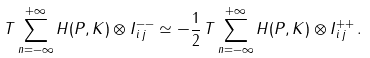Convert formula to latex. <formula><loc_0><loc_0><loc_500><loc_500>T \sum _ { n = - \infty } ^ { + \infty } H ( P , K ) \otimes I ^ { - - } _ { \, i \, j } \simeq - \frac { 1 } { 2 } \, T \sum _ { n = - \infty } ^ { + \infty } H ( P , K ) \otimes I ^ { + + } _ { \, i \, j } \, .</formula> 